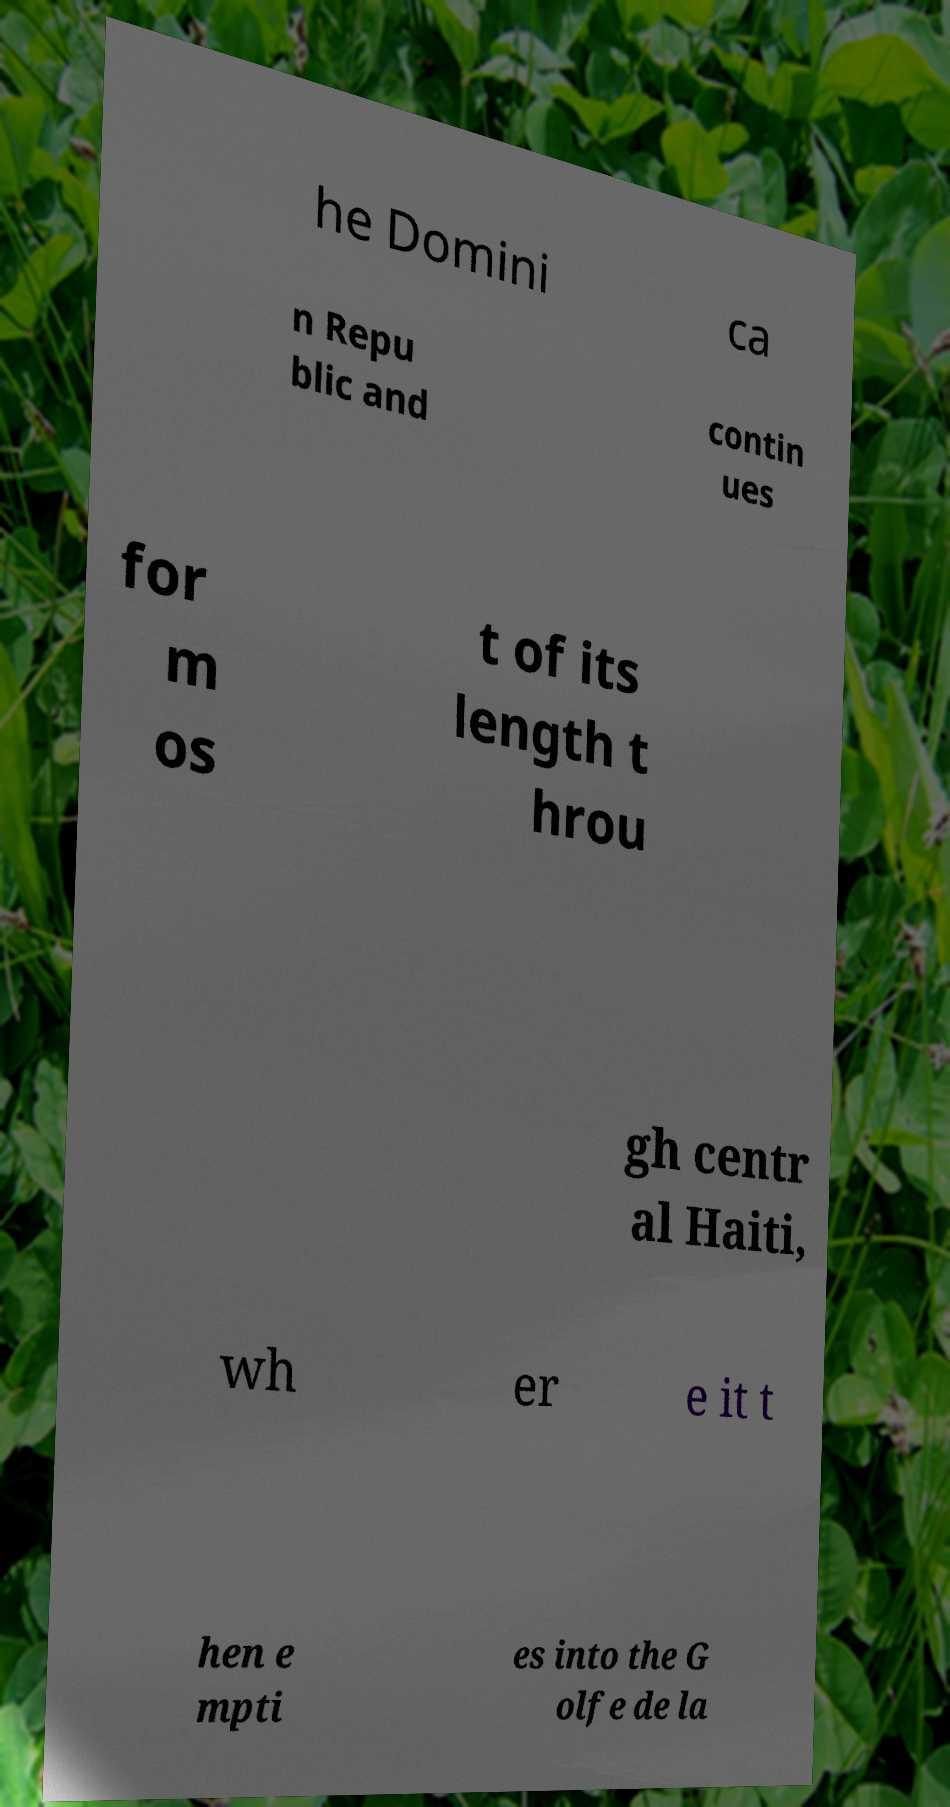Please identify and transcribe the text found in this image. he Domini ca n Repu blic and contin ues for m os t of its length t hrou gh centr al Haiti, wh er e it t hen e mpti es into the G olfe de la 